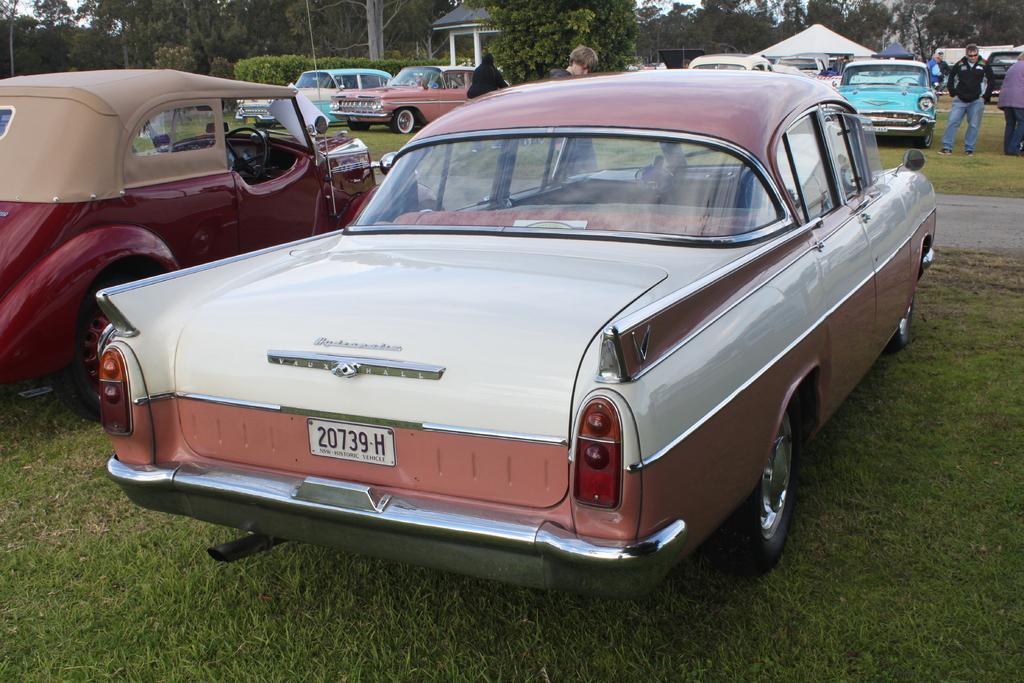Please provide a concise description of this image. In this picture we can see some vehicles parked on the path and some are standing. Behind the people there is a stall, trees and the sky. 